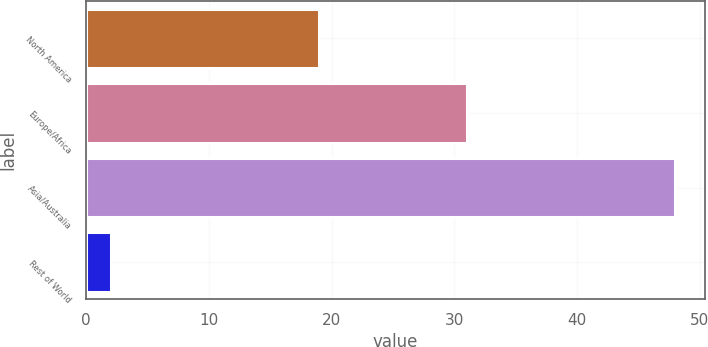Convert chart. <chart><loc_0><loc_0><loc_500><loc_500><bar_chart><fcel>North America<fcel>Europe/Africa<fcel>Asia/Australia<fcel>Rest of World<nl><fcel>19<fcel>31<fcel>48<fcel>2<nl></chart> 